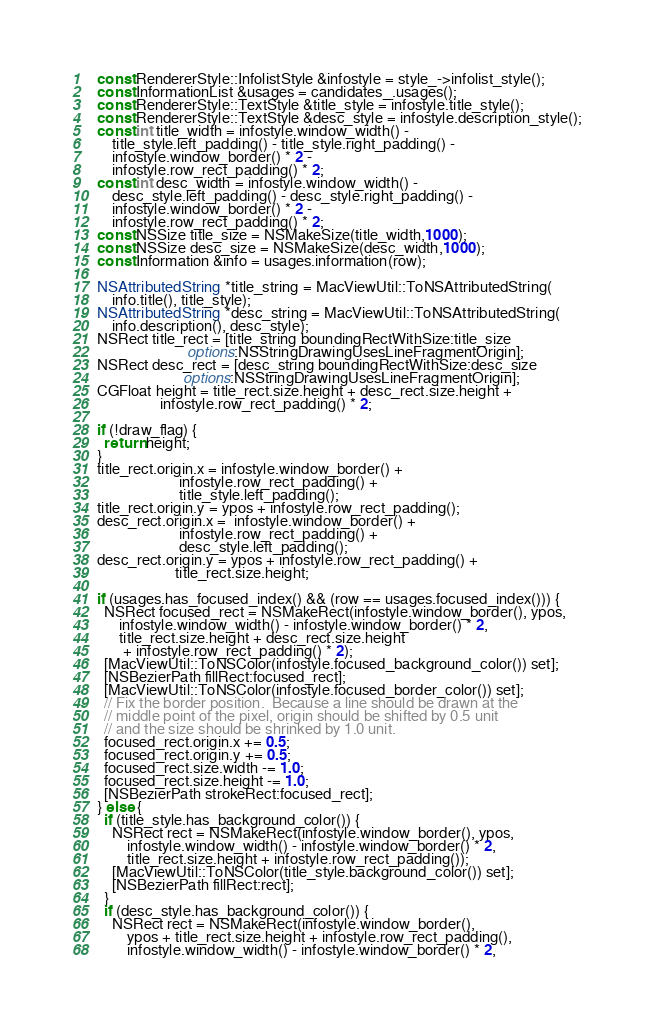Convert code to text. <code><loc_0><loc_0><loc_500><loc_500><_ObjectiveC_>  const RendererStyle::InfolistStyle &infostyle = style_->infolist_style();
  const InformationList &usages = candidates_.usages();
  const RendererStyle::TextStyle &title_style = infostyle.title_style();
  const RendererStyle::TextStyle &desc_style = infostyle.description_style();
  const int title_width = infostyle.window_width() -
      title_style.left_padding() - title_style.right_padding() -
      infostyle.window_border() * 2 -
      infostyle.row_rect_padding() * 2;
  const int desc_width = infostyle.window_width() -
      desc_style.left_padding() - desc_style.right_padding() -
      infostyle.window_border() * 2 -
      infostyle.row_rect_padding() * 2;
  const NSSize title_size = NSMakeSize(title_width,1000);
  const NSSize desc_size = NSMakeSize(desc_width,1000);
  const Information &info = usages.information(row);

  NSAttributedString *title_string = MacViewUtil::ToNSAttributedString(
      info.title(), title_style);
  NSAttributedString *desc_string = MacViewUtil::ToNSAttributedString(
      info.description(), desc_style);
  NSRect title_rect = [title_string boundingRectWithSize:title_size
                          options:NSStringDrawingUsesLineFragmentOrigin];
  NSRect desc_rect = [desc_string boundingRectWithSize:desc_size
                         options:NSStringDrawingUsesLineFragmentOrigin];
  CGFloat height = title_rect.size.height + desc_rect.size.height +
                   infostyle.row_rect_padding() * 2;

  if (!draw_flag) {
    return height;
  }
  title_rect.origin.x = infostyle.window_border() +
                        infostyle.row_rect_padding() +
                        title_style.left_padding();
  title_rect.origin.y = ypos + infostyle.row_rect_padding();
  desc_rect.origin.x =  infostyle.window_border() +
                        infostyle.row_rect_padding() +
                        desc_style.left_padding();
  desc_rect.origin.y = ypos + infostyle.row_rect_padding() +
                       title_rect.size.height;

  if (usages.has_focused_index() && (row == usages.focused_index())) {
    NSRect focused_rect = NSMakeRect(infostyle.window_border(), ypos,
        infostyle.window_width() - infostyle.window_border() * 2,
        title_rect.size.height + desc_rect.size.height
         + infostyle.row_rect_padding() * 2);
    [MacViewUtil::ToNSColor(infostyle.focused_background_color()) set];
    [NSBezierPath fillRect:focused_rect];
    [MacViewUtil::ToNSColor(infostyle.focused_border_color()) set];
    // Fix the border position.  Because a line should be drawn at the
    // middle point of the pixel, origin should be shifted by 0.5 unit
    // and the size should be shrinked by 1.0 unit.
    focused_rect.origin.x += 0.5;
    focused_rect.origin.y += 0.5;
    focused_rect.size.width -= 1.0;
    focused_rect.size.height -= 1.0;
    [NSBezierPath strokeRect:focused_rect];
  } else {
    if (title_style.has_background_color()) {
      NSRect rect = NSMakeRect(infostyle.window_border(), ypos,
          infostyle.window_width() - infostyle.window_border() * 2,
          title_rect.size.height + infostyle.row_rect_padding());
      [MacViewUtil::ToNSColor(title_style.background_color()) set];
      [NSBezierPath fillRect:rect];
    }
    if (desc_style.has_background_color()) {
      NSRect rect = NSMakeRect(infostyle.window_border(),
          ypos + title_rect.size.height + infostyle.row_rect_padding(),
          infostyle.window_width() - infostyle.window_border() * 2,</code> 